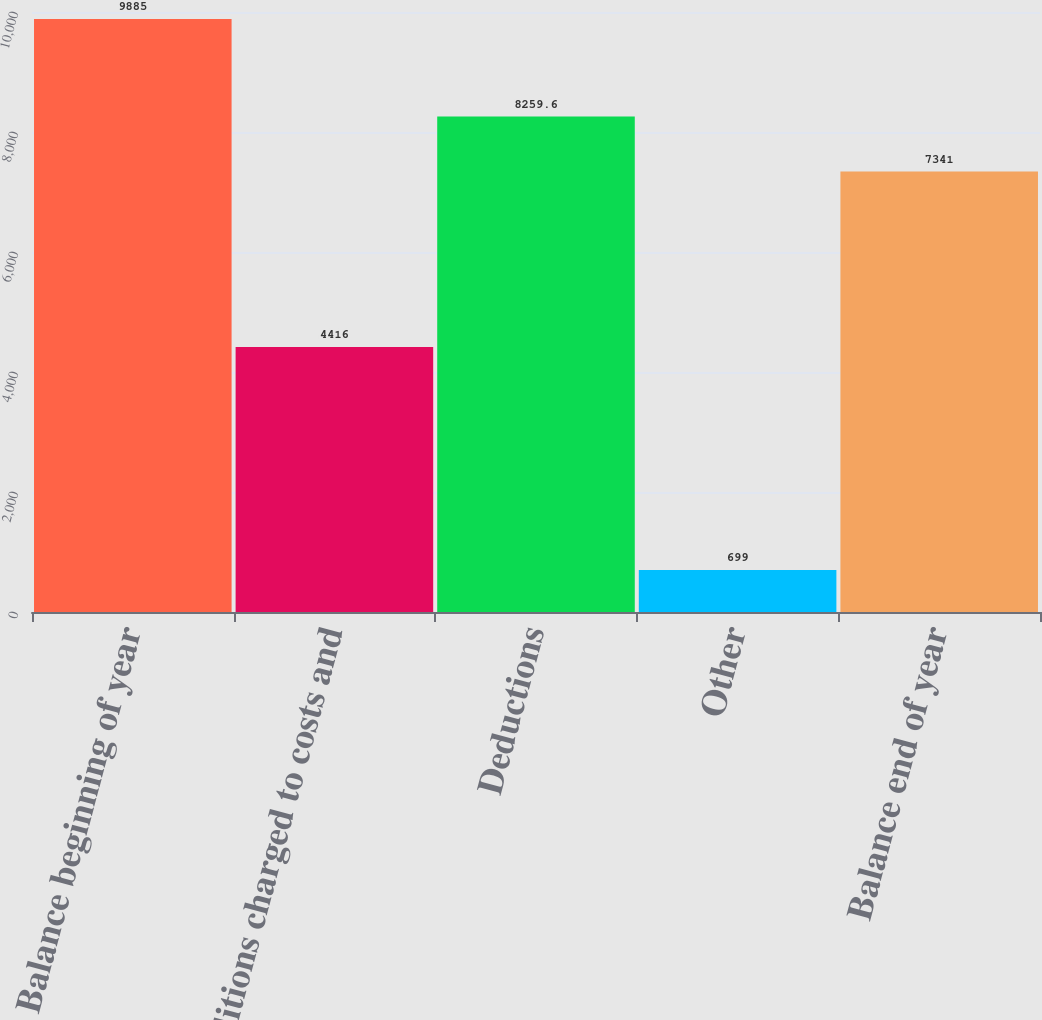<chart> <loc_0><loc_0><loc_500><loc_500><bar_chart><fcel>Balance beginning of year<fcel>Additions charged to costs and<fcel>Deductions<fcel>Other<fcel>Balance end of year<nl><fcel>9885<fcel>4416<fcel>8259.6<fcel>699<fcel>7341<nl></chart> 